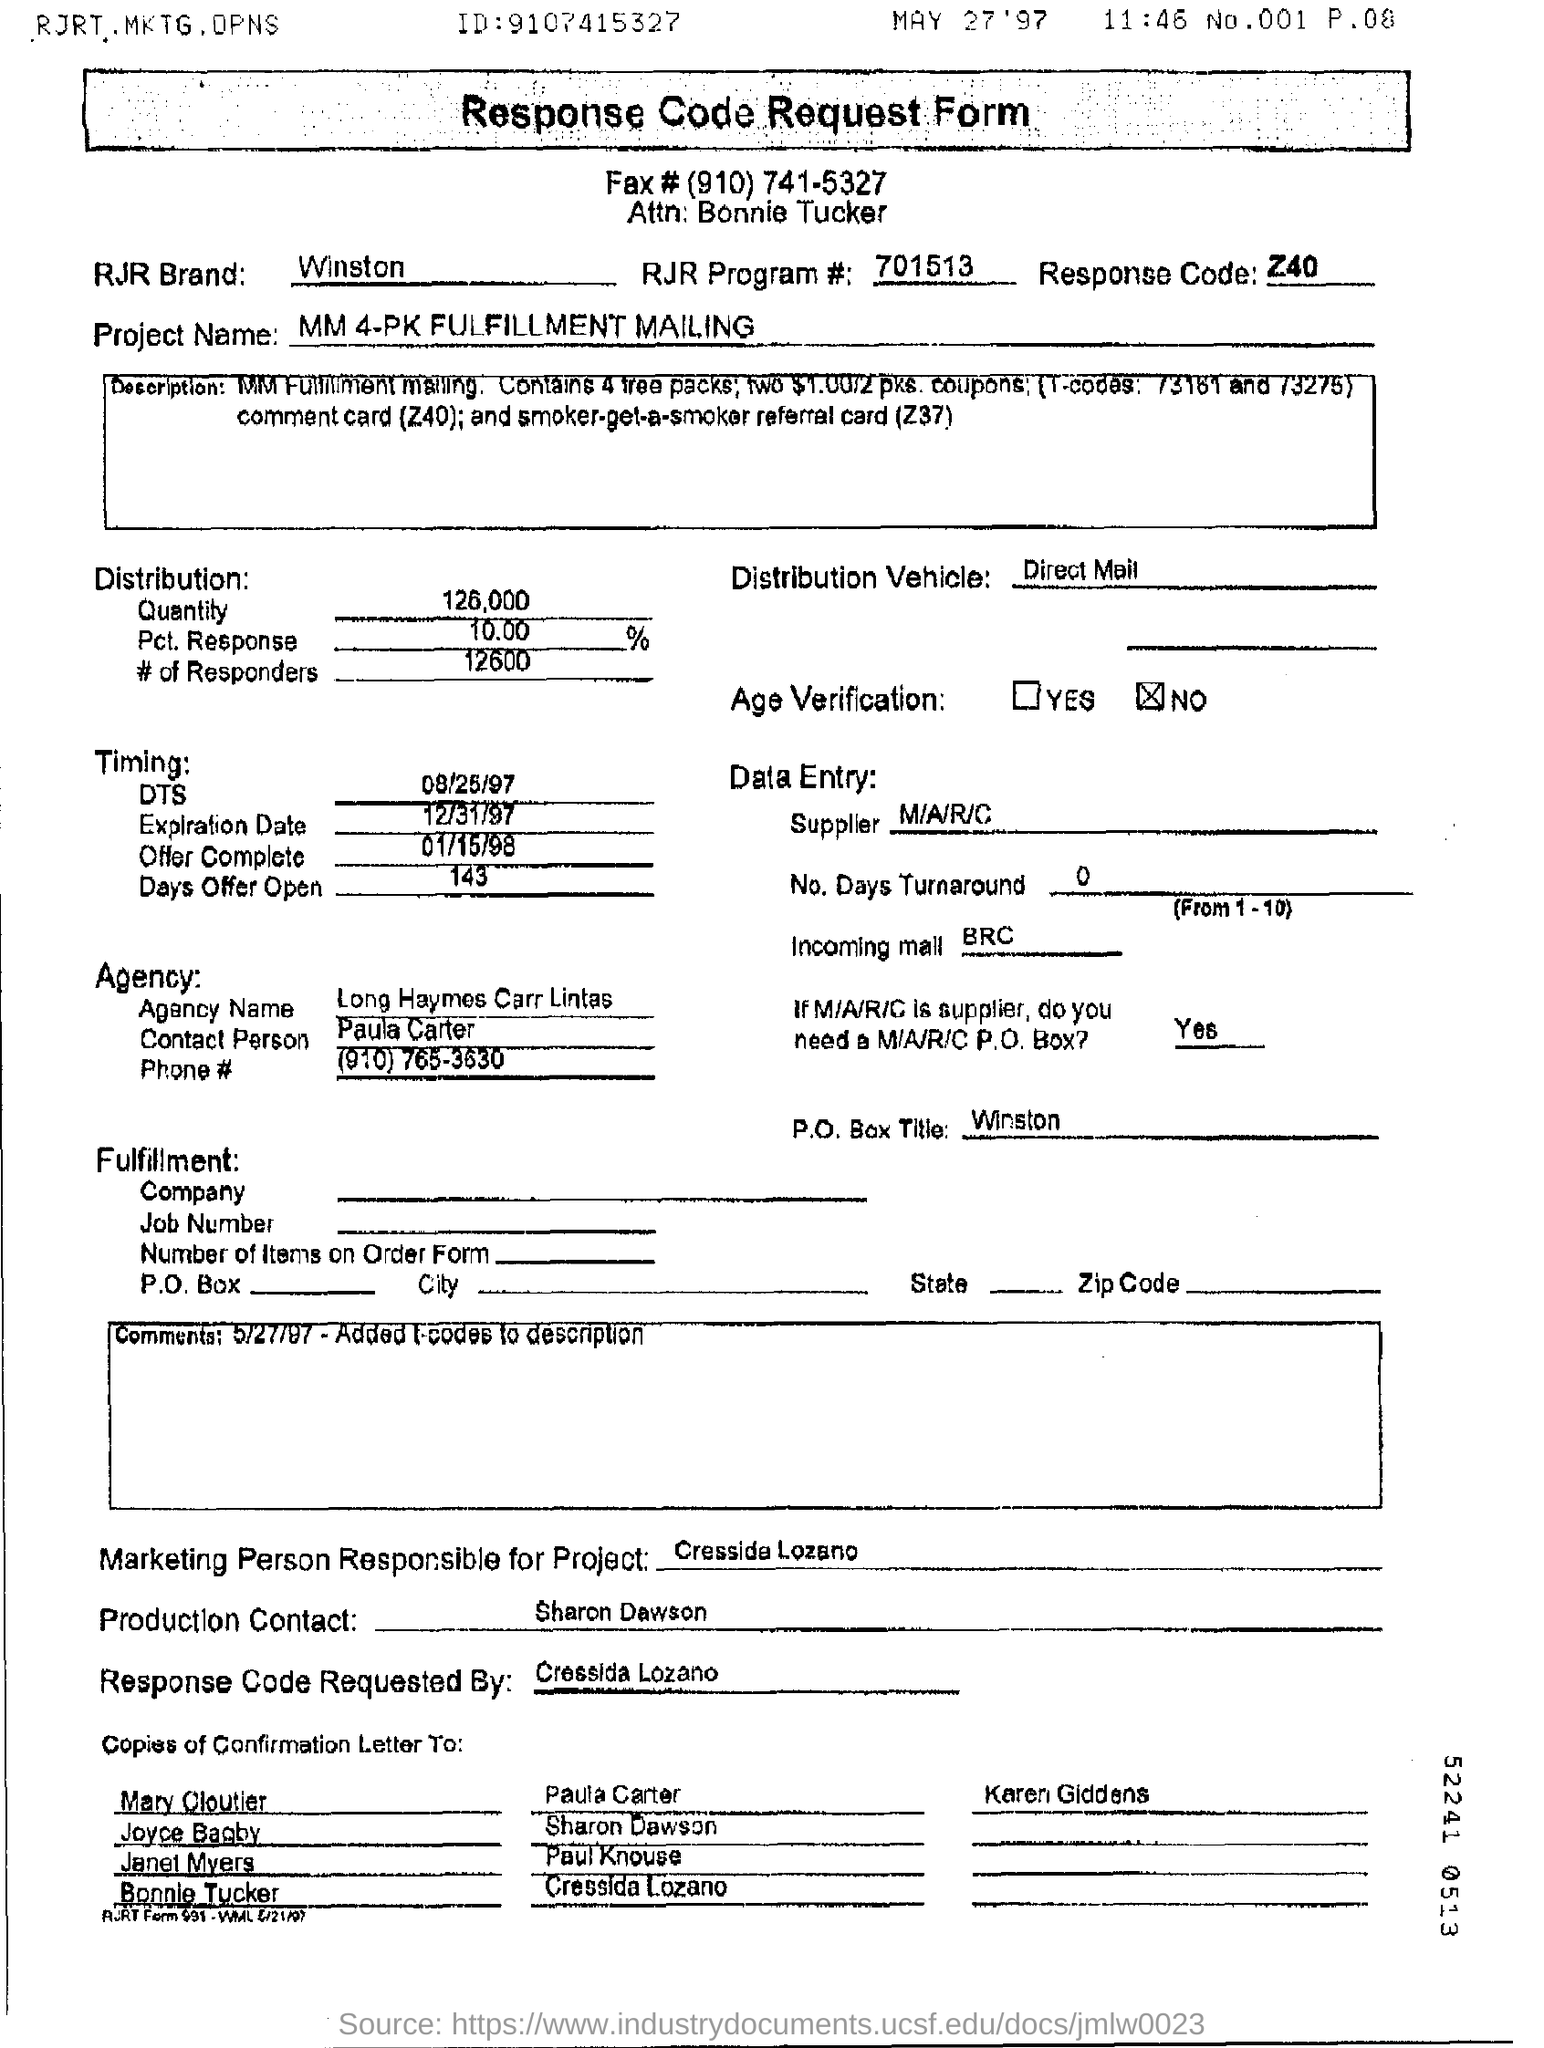Draw attention to some important aspects in this diagram. The response code is Z40. 